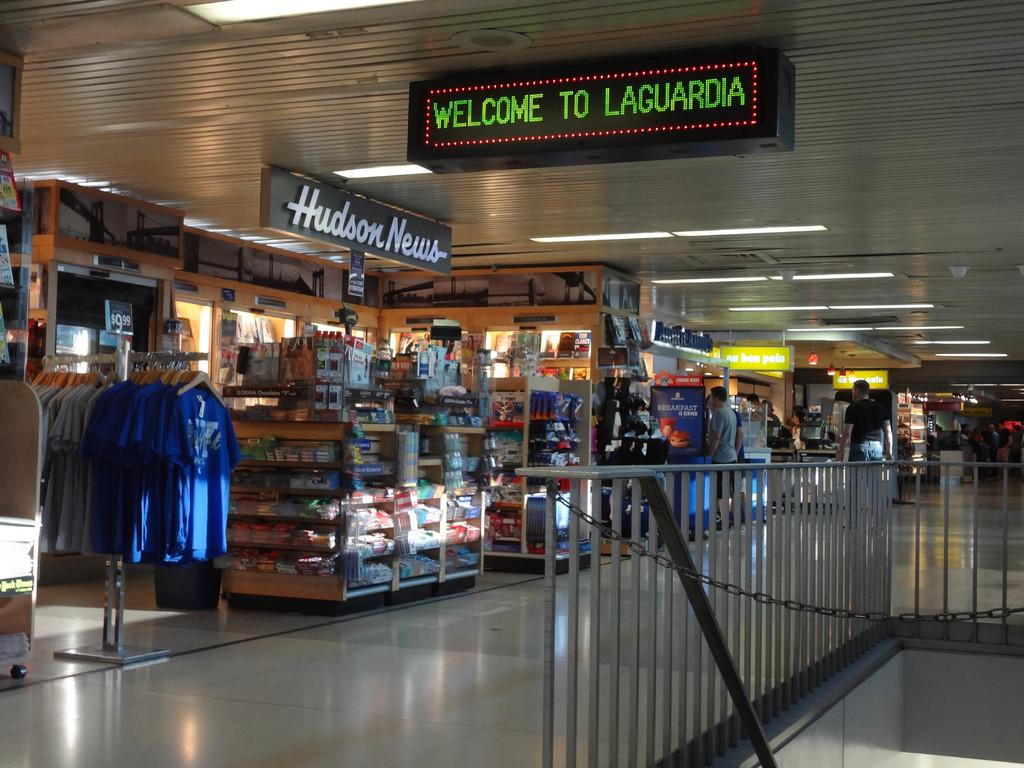<image>
Share a concise interpretation of the image provided. An airport scene with Welcome to Laguardia in green 